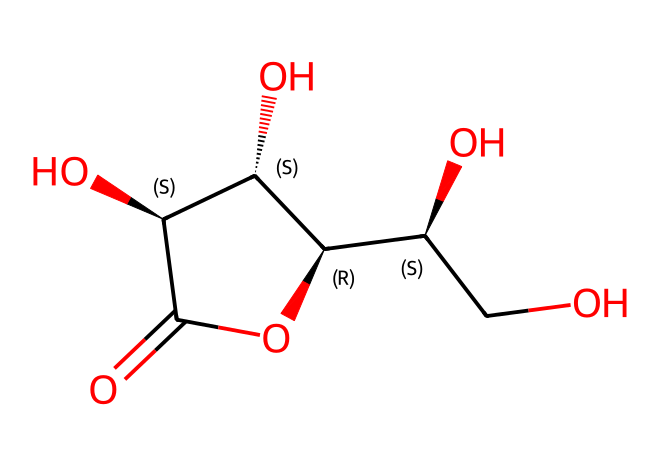What is the molecular formula of this compound? To determine the molecular formula, we analyze the SMILES notation. The structure contains Carbon (C), Hydrogen (H), and Oxygen (O) atoms. Counting these atoms in the structure gives us C6, H8, and O6. Therefore, the molecular formula is C6H8O6.
Answer: C6H8O6 How many oxygen atoms are in ascorbic acid? By examining the molecular formula C6H8O6, we can directly see that it contains 6 oxygen atoms.
Answer: 6 What is the cyclical arrangement in the structure? The structure includes a cyclic arrangement denoted by the ring formed between the carbon atoms and the oxygen. The notation "C1" identifies that this is the start of a ring which includes multiple atoms connected in a loop.
Answer: ring Which functional group is present in ascorbic acid? Looking at the structure, we see multiple hydroxyl (-OH) groups attached to the carbons, indicating that this compound has alcohol functional groups. This is confirmed by observing the presence of -OH groups connected to various carbon atoms in the structure.
Answer: alcohol Is ascorbic acid a reducing agent? Ascorbic acid acts as a reducing agent because it can donate electrons in biochemical reactions, which is evident from its structure containing easily oxidizable sites, particularly the hydroxyl groups.
Answer: yes How does the hydroxyl group influence the chemical's properties? The presence of hydroxyl groups increases the solubility of ascorbic acid in water and contributes to its antioxidant properties by making it more reactive toward radical species. The hydroxyl groups can engage in hydrogen bonding, which enhances its solubility in polar solvents.
Answer: solubility and antioxidant properties 